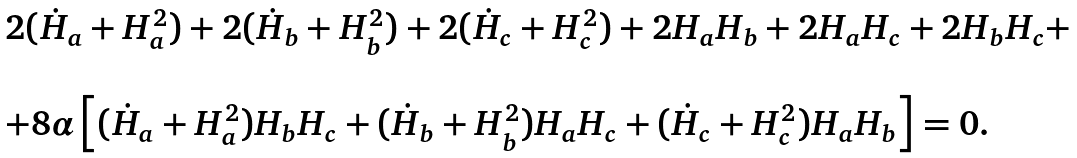Convert formula to latex. <formula><loc_0><loc_0><loc_500><loc_500>\begin{array} { l } 2 ( \dot { H } _ { a } + H _ { a } ^ { 2 } ) + 2 ( \dot { H } _ { b } + H _ { b } ^ { 2 } ) + 2 ( \dot { H } _ { c } + H _ { c } ^ { 2 } ) + 2 H _ { a } H _ { b } + 2 H _ { a } H _ { c } + 2 H _ { b } H _ { c } + \\ \\ + 8 \alpha \left [ ( \dot { H } _ { a } + H _ { a } ^ { 2 } ) H _ { b } H _ { c } + ( \dot { H } _ { b } + H _ { b } ^ { 2 } ) H _ { a } H _ { c } + ( \dot { H } _ { c } + H _ { c } ^ { 2 } ) H _ { a } H _ { b } \right ] = 0 . \end{array}</formula> 